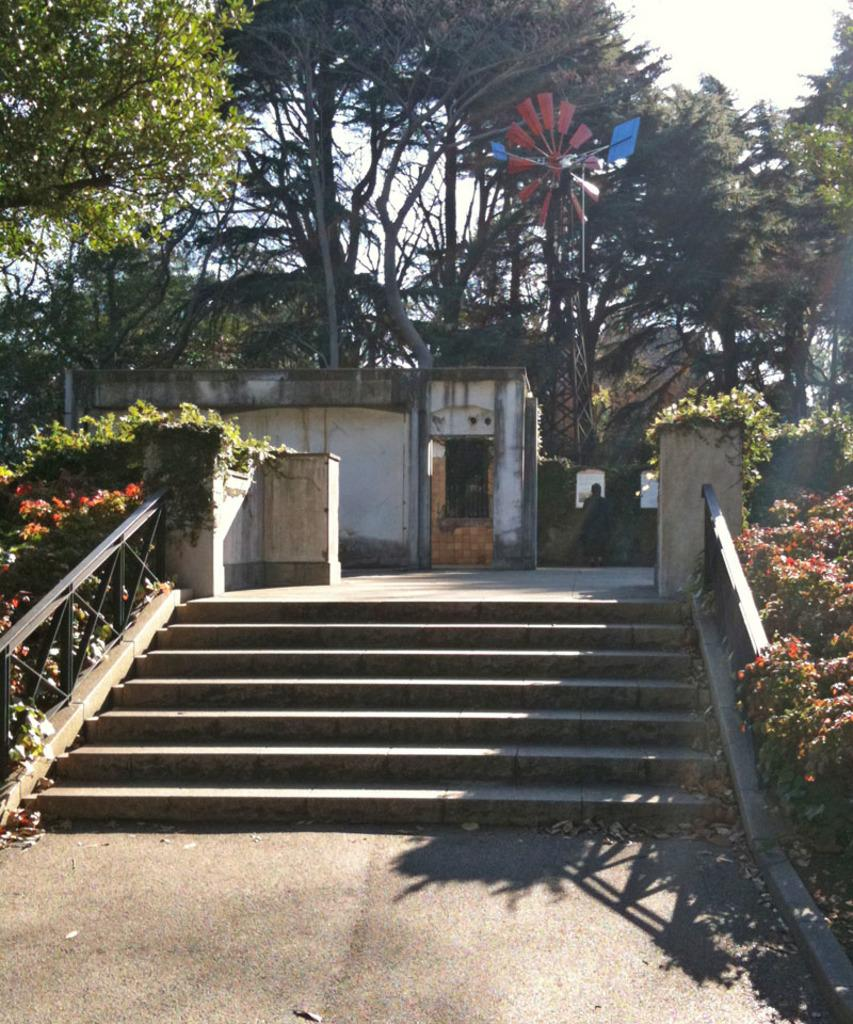What type of structure is present in the image? There is a shed in the image. What architectural feature can be seen in the image? There are stairs in the image. What type of vegetation is present in the image? There are plants in the image. What can be seen in the background of the image? There are trees and the sky visible in the background of the image. Can you describe the object in the image? There is an object in the image, but its specific nature is not mentioned in the facts. Is there a person in the image? Yes, there is a person in the image. What type of scissors are being used to trim the boundary in the image? There is no mention of scissors or a boundary in the image. What color is the orange that the person is holding in the image? There is no orange present in the image. 